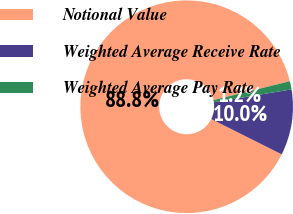<chart> <loc_0><loc_0><loc_500><loc_500><pie_chart><fcel>Notional Value<fcel>Weighted Average Receive Rate<fcel>Weighted Average Pay Rate<nl><fcel>88.75%<fcel>10.0%<fcel>1.25%<nl></chart> 